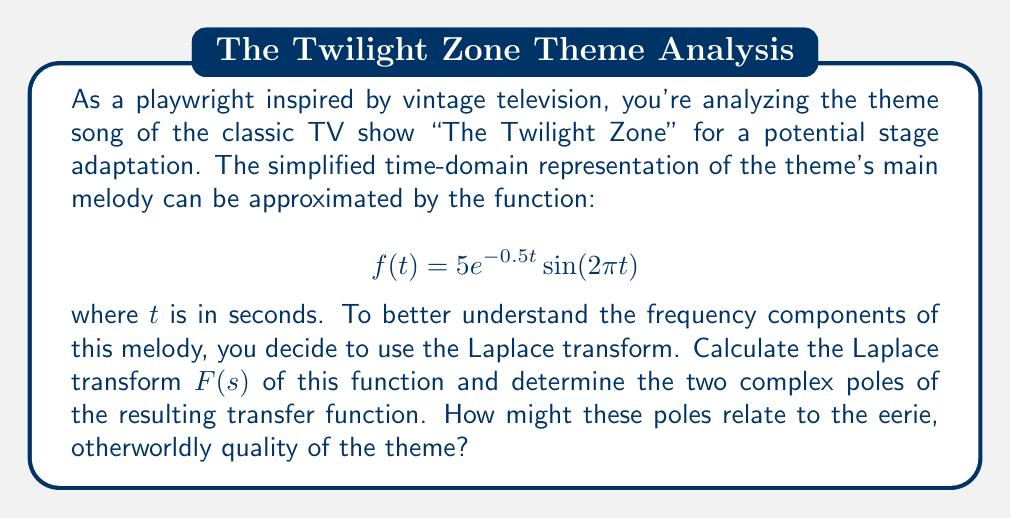Give your solution to this math problem. Let's approach this step-by-step:

1) The Laplace transform of $f(t) = 5e^{-0.5t}\sin(2\pi t)$ is given by:

   $$F(s) = \mathcal{L}\{5e^{-0.5t}\sin(2\pi t)\}$$

2) We can use the Laplace transform property for exponential functions:
   
   $$\mathcal{L}\{e^{at}g(t)\} = G(s-a)$$

   where $G(s)$ is the Laplace transform of $g(t)$.

3) In our case, $a = -0.5$ and $g(t) = 5\sin(2\pi t)$. So we need to find:

   $$F(s) = 5\mathcal{L}\{\sin(2\pi t)\}_{s+0.5}$$

4) The Laplace transform of $\sin(\omega t)$ is $\frac{\omega}{s^2 + \omega^2}$. Here, $\omega = 2\pi$.

5) Therefore:

   $$F(s) = 5 \cdot \frac{2\pi}{(s+0.5)^2 + (2\pi)^2}$$

6) Simplifying:

   $$F(s) = \frac{10\pi}{(s+0.5)^2 + 4\pi^2}$$

7) To find the poles, we set the denominator to zero:

   $$(s+0.5)^2 + 4\pi^2 = 0$$

8) Solving this equation:

   $$s+0.5 = \pm 2\pi i$$
   $$s = -0.5 \pm 2\pi i$$

9) Therefore, the two complex poles are:

   $$s_1 = -0.5 + 2\pi i \quad \text{and} \quad s_2 = -0.5 - 2\pi i$$

These poles relate to the eerie quality of the theme because:
- The real part (-0.5) indicates the decay rate of the sound.
- The imaginary parts (±2πi) correspond to the oscillation frequency, which gives the theme its distinctive pitch and otherworldly feel.
Answer: $s_1 = -0.5 + 2\pi i$, $s_2 = -0.5 - 2\pi i$ 